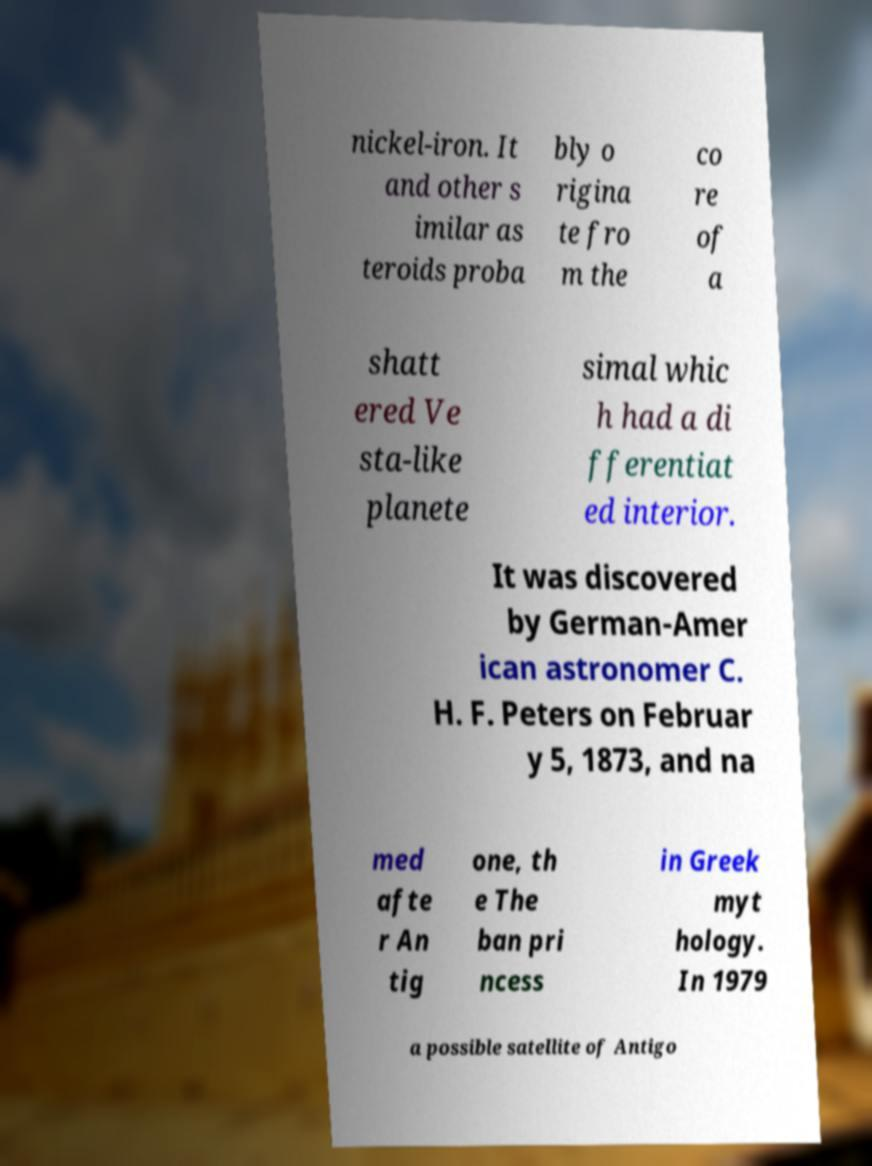I need the written content from this picture converted into text. Can you do that? nickel-iron. It and other s imilar as teroids proba bly o rigina te fro m the co re of a shatt ered Ve sta-like planete simal whic h had a di fferentiat ed interior. It was discovered by German-Amer ican astronomer C. H. F. Peters on Februar y 5, 1873, and na med afte r An tig one, th e The ban pri ncess in Greek myt hology. In 1979 a possible satellite of Antigo 